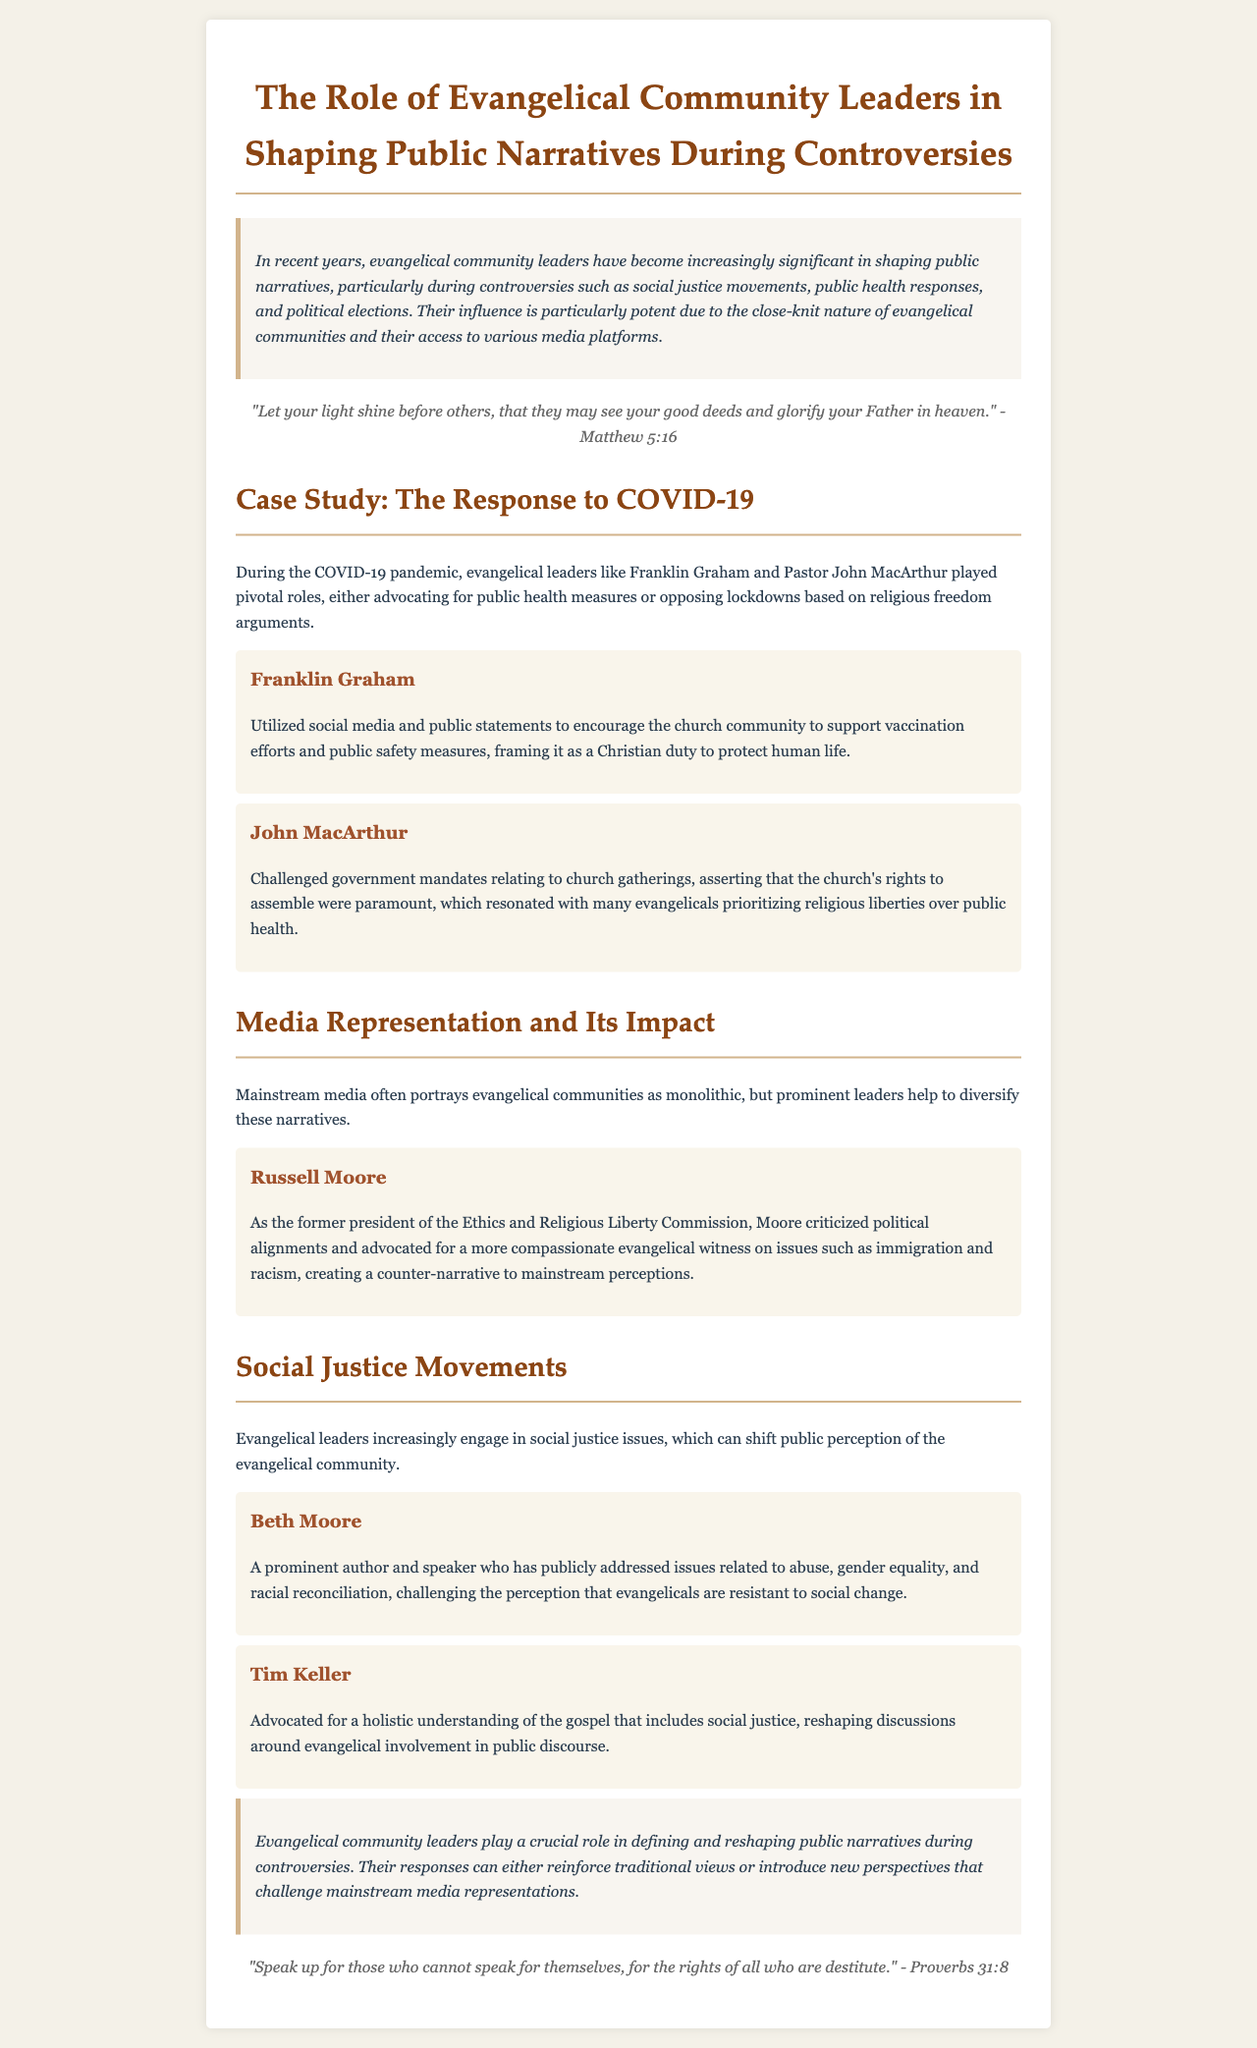What is the main focus of the report? The main focus of the report is on how evangelical community leaders shape public narratives during controversies.
Answer: Shaping public narratives during controversies Who is mentioned as advocating for vaccination efforts? Franklin Graham is mentioned as encouraging support for vaccination efforts within the church community.
Answer: Franklin Graham What does John MacArthur assert about church gatherings? John MacArthur asserts that the church's rights to assemble are paramount.
Answer: Church's rights to assemble Which social justice issue has Beth Moore publicly addressed? Beth Moore has publicly addressed issues related to abuse, gender equality, and racial reconciliation.
Answer: Abuse, gender equality, and racial reconciliation Who is noted for advocating a holistic understanding of the gospel? Tim Keller is noted for advocating a holistic understanding of the gospel that includes social justice.
Answer: Tim Keller How do evangelical leaders help counter mainstream media narratives? Prominent leaders like Russell Moore help to diversify narratives that portray evangelical communities as monolithic.
Answer: Diversify narratives What is the scriptural reference included in the document? The scriptural reference is "Let your light shine before others..."
Answer: "Let your light shine before others..." What role do evangelical community leaders play according to the conclusion? According to the conclusion, they play a crucial role in defining and reshaping public narratives during controversies.
Answer: Defining and reshaping public narratives Which leader challenged government mandates related to COVID-19? John MacArthur challenged government mandates relating to church gatherings.
Answer: John MacArthur 